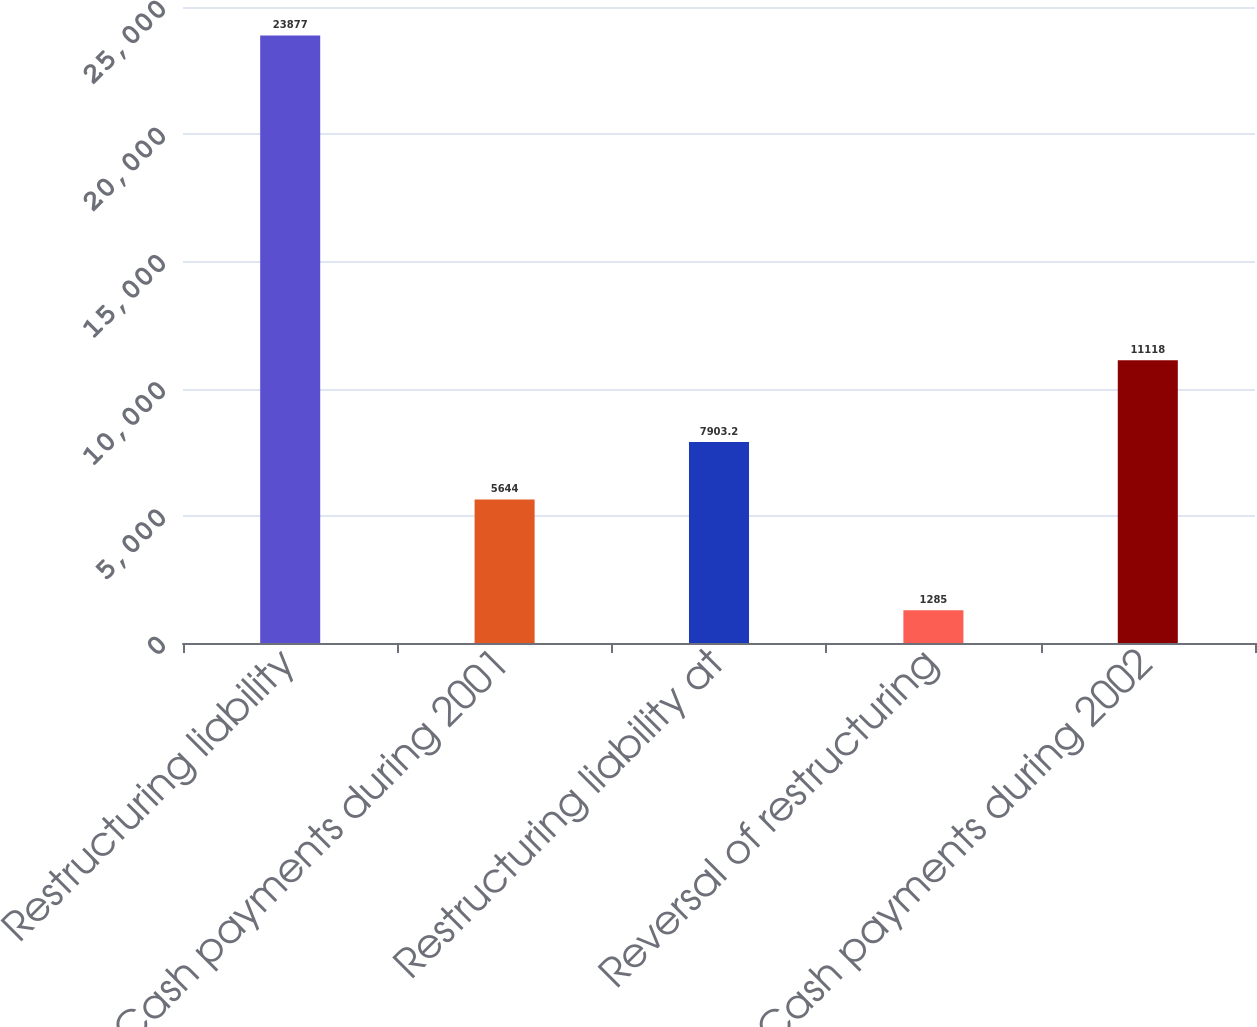Convert chart to OTSL. <chart><loc_0><loc_0><loc_500><loc_500><bar_chart><fcel>Restructuring liability<fcel>Cash payments during 2001<fcel>Restructuring liability at<fcel>Reversal of restructuring<fcel>Cash payments during 2002<nl><fcel>23877<fcel>5644<fcel>7903.2<fcel>1285<fcel>11118<nl></chart> 